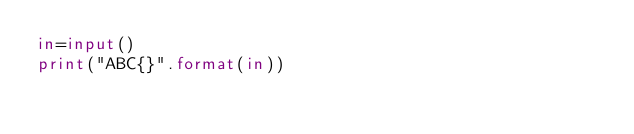Convert code to text. <code><loc_0><loc_0><loc_500><loc_500><_Python_>in=input()
print("ABC{}".format(in))</code> 